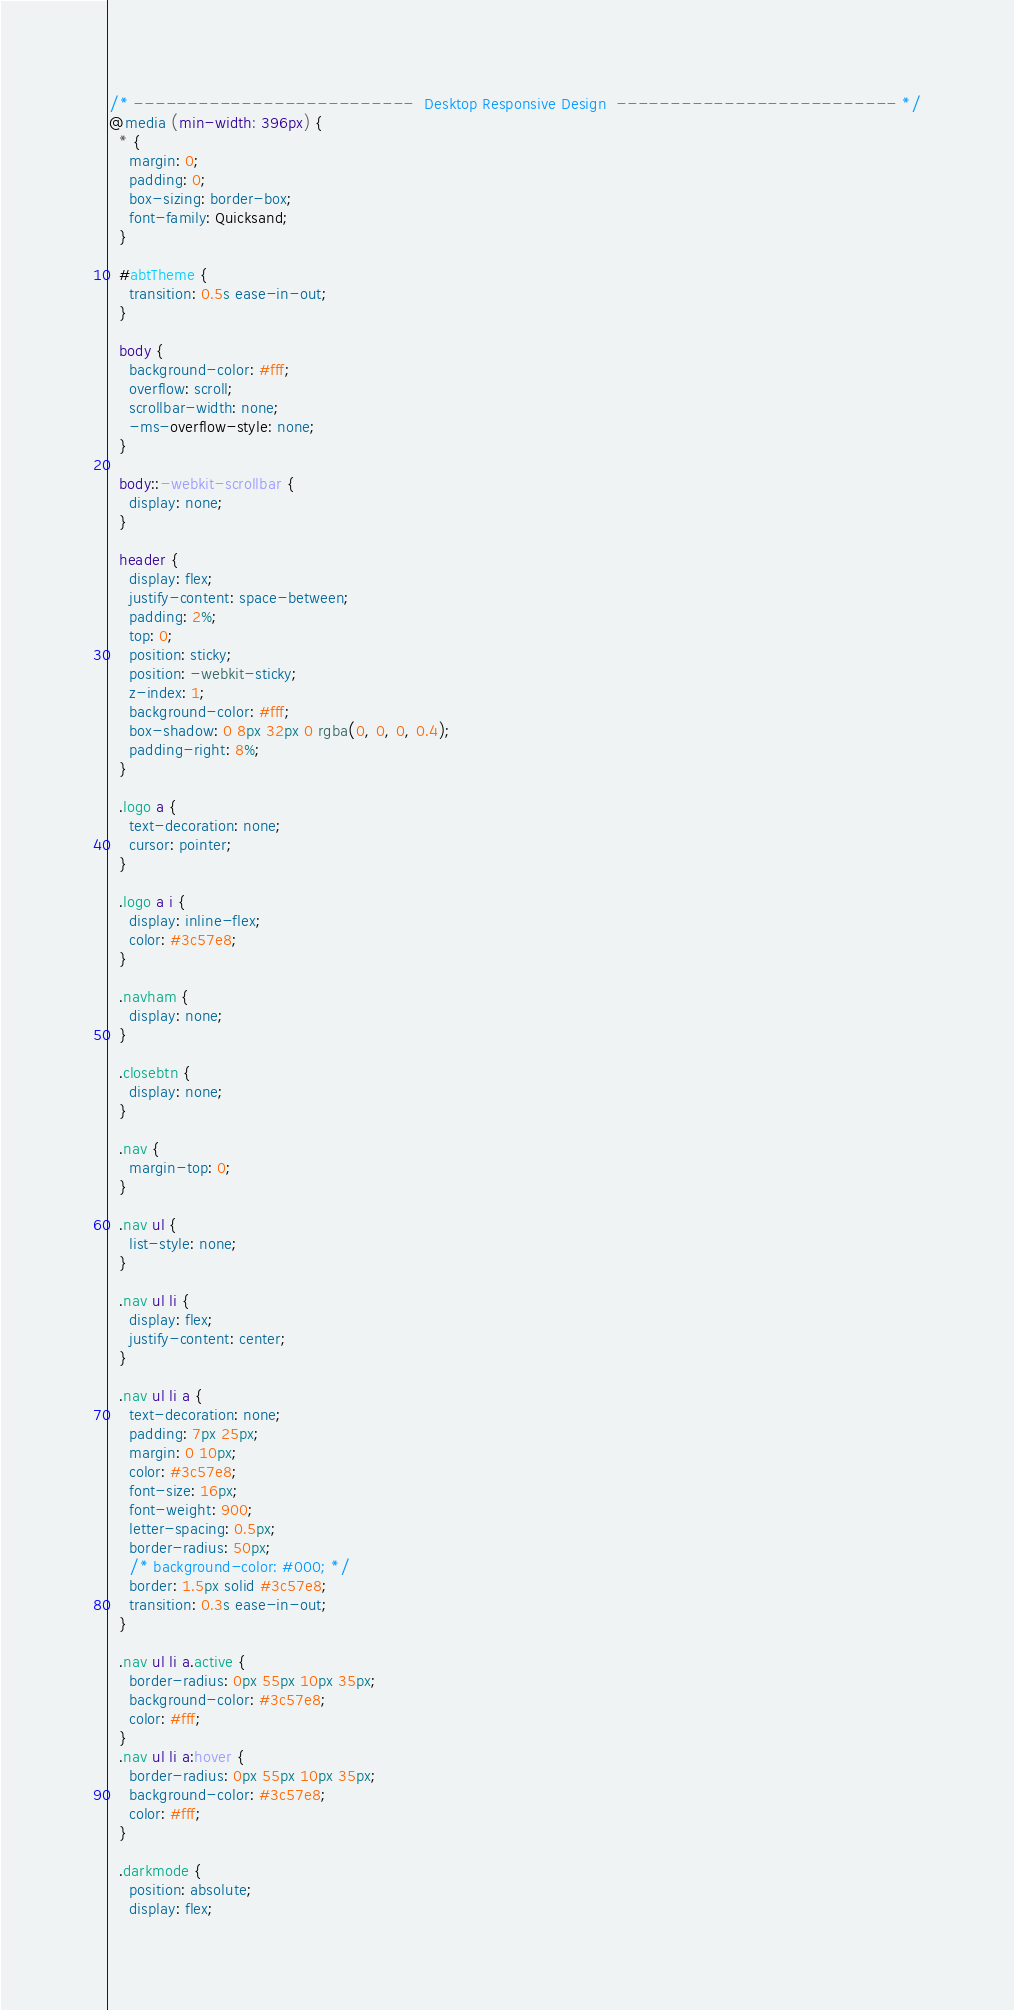Convert code to text. <code><loc_0><loc_0><loc_500><loc_500><_CSS_>/* --------------------------  Desktop Responsive Design  -------------------------- */
@media (min-width: 396px) {
  * {
    margin: 0;
    padding: 0;
    box-sizing: border-box;
    font-family: Quicksand;
  }

  #abtTheme {
    transition: 0.5s ease-in-out;
  }

  body {
    background-color: #fff;
    overflow: scroll;
    scrollbar-width: none;
    -ms-overflow-style: none;
  }

  body::-webkit-scrollbar {
    display: none;
  }

  header {
    display: flex;
    justify-content: space-between;
    padding: 2%;
    top: 0;
    position: sticky;
    position: -webkit-sticky;
    z-index: 1;
    background-color: #fff;
    box-shadow: 0 8px 32px 0 rgba(0, 0, 0, 0.4);
    padding-right: 8%;
  }

  .logo a {
    text-decoration: none;
    cursor: pointer;
  }

  .logo a i {
    display: inline-flex;
    color: #3c57e8;
  }

  .navham {
    display: none;
  }

  .closebtn {
    display: none;
  }

  .nav {
    margin-top: 0;
  }

  .nav ul {
    list-style: none;
  }

  .nav ul li {
    display: flex;
    justify-content: center;
  }

  .nav ul li a {
    text-decoration: none;
    padding: 7px 25px;
    margin: 0 10px;
    color: #3c57e8;
    font-size: 16px;
    font-weight: 900;
    letter-spacing: 0.5px;
    border-radius: 50px;
    /* background-color: #000; */
    border: 1.5px solid #3c57e8;
    transition: 0.3s ease-in-out;
  }

  .nav ul li a.active {
    border-radius: 0px 55px 10px 35px;
    background-color: #3c57e8;
    color: #fff;
  }
  .nav ul li a:hover {
    border-radius: 0px 55px 10px 35px;
    background-color: #3c57e8;
    color: #fff;
  }

  .darkmode {
    position: absolute;
    display: flex;</code> 